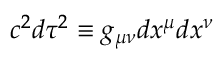Convert formula to latex. <formula><loc_0><loc_0><loc_500><loc_500>c ^ { 2 } d \tau ^ { 2 } \equiv g _ { \mu \nu } d x ^ { \mu } d x ^ { \nu }</formula> 